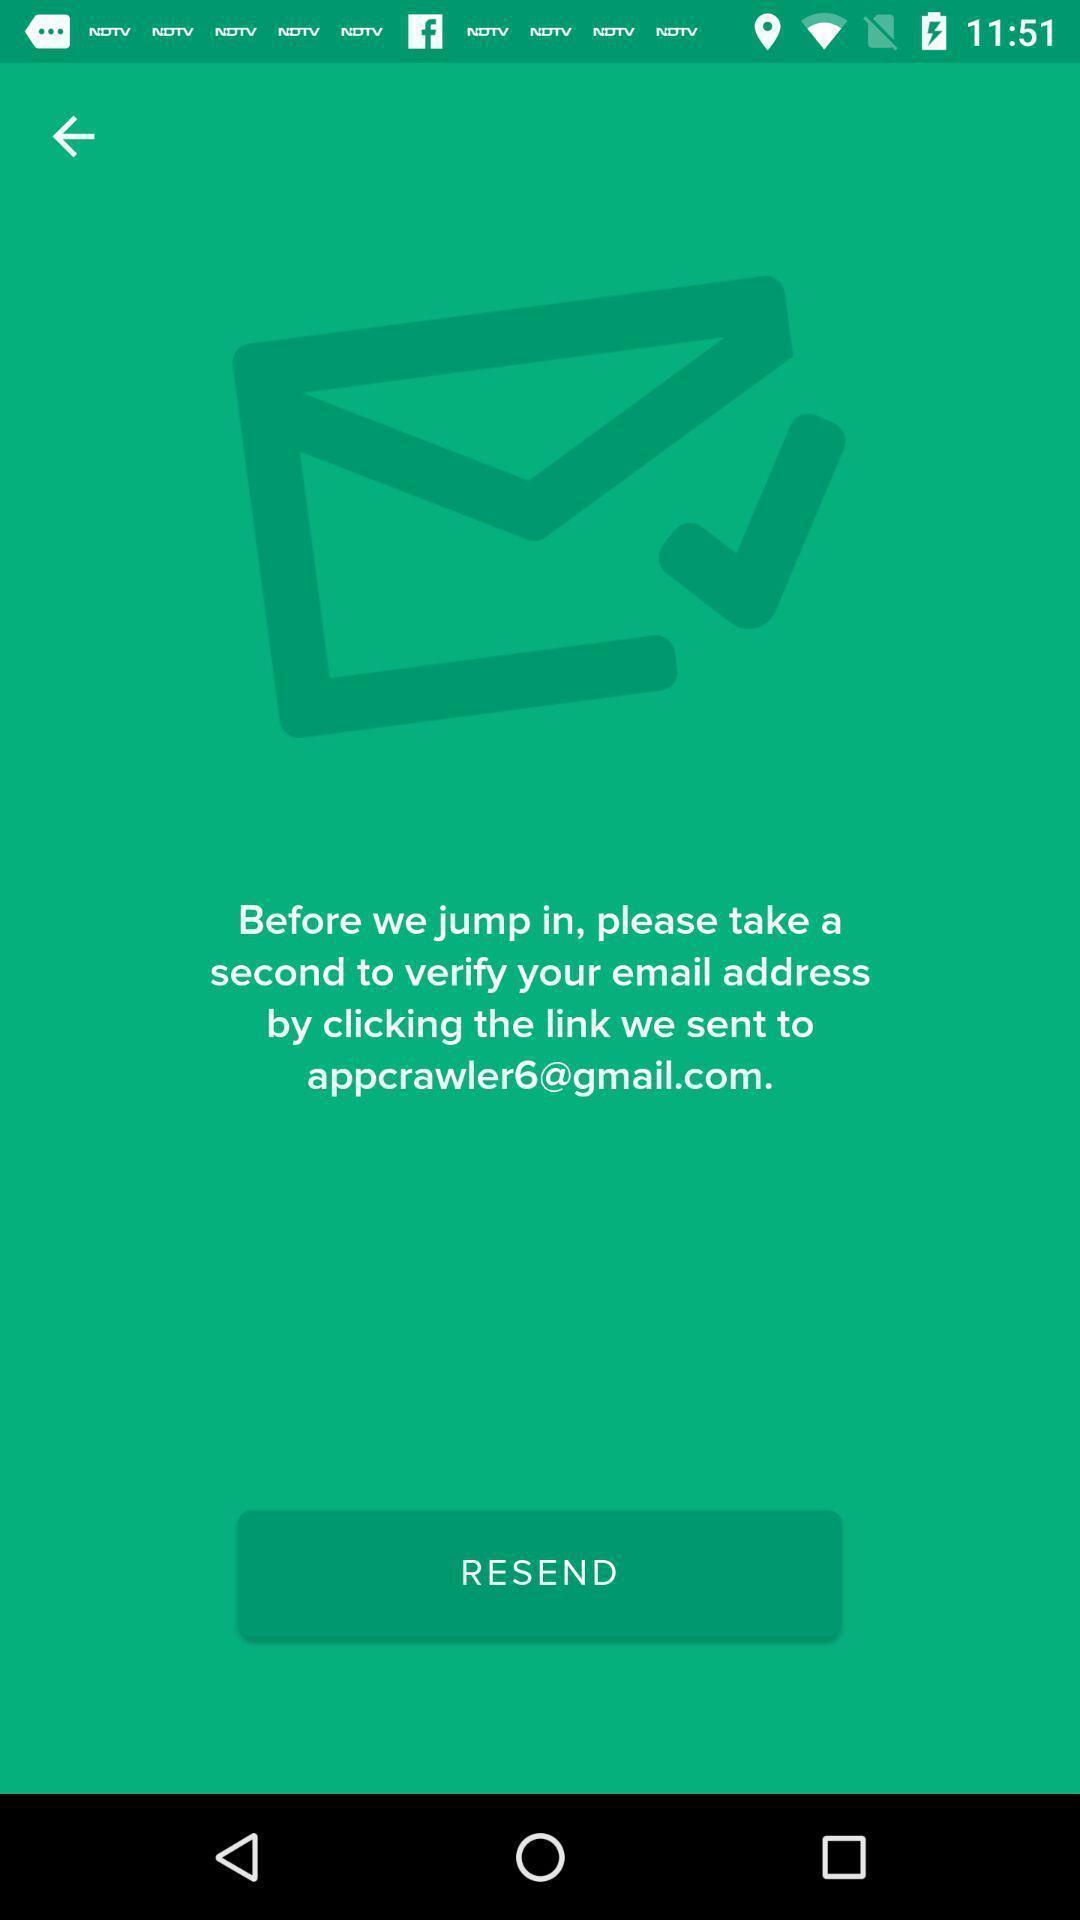What details can you identify in this image? Resend button page on an app. 